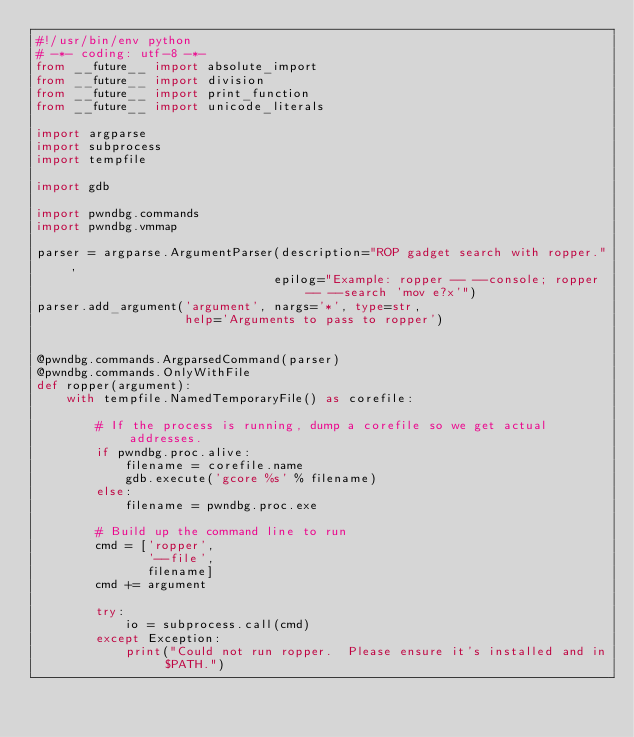<code> <loc_0><loc_0><loc_500><loc_500><_Python_>#!/usr/bin/env python
# -*- coding: utf-8 -*-
from __future__ import absolute_import
from __future__ import division
from __future__ import print_function
from __future__ import unicode_literals

import argparse
import subprocess
import tempfile

import gdb

import pwndbg.commands
import pwndbg.vmmap

parser = argparse.ArgumentParser(description="ROP gadget search with ropper.",
                                epilog="Example: ropper -- --console; ropper -- --search 'mov e?x'")
parser.add_argument('argument', nargs='*', type=str,
                    help='Arguments to pass to ropper')


@pwndbg.commands.ArgparsedCommand(parser)
@pwndbg.commands.OnlyWithFile
def ropper(argument):
    with tempfile.NamedTemporaryFile() as corefile:

        # If the process is running, dump a corefile so we get actual addresses.
        if pwndbg.proc.alive:
            filename = corefile.name
            gdb.execute('gcore %s' % filename)
        else:
            filename = pwndbg.proc.exe

        # Build up the command line to run
        cmd = ['ropper',
               '--file',
               filename] 
        cmd += argument

        try:
            io = subprocess.call(cmd)
        except Exception:
            print("Could not run ropper.  Please ensure it's installed and in $PATH.")
</code> 